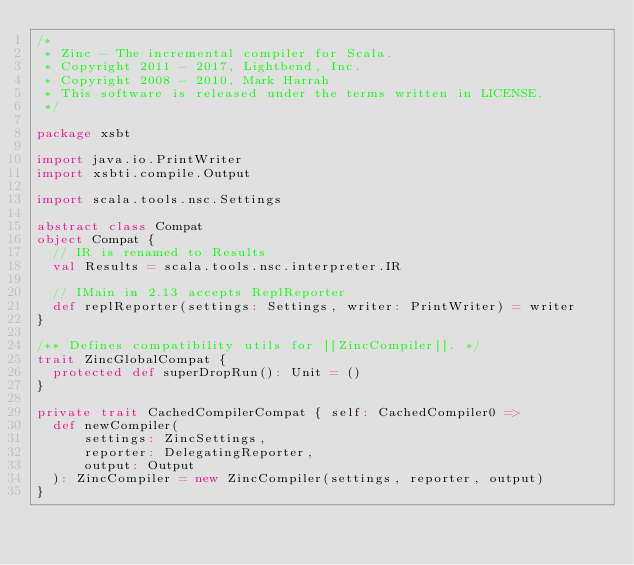<code> <loc_0><loc_0><loc_500><loc_500><_Scala_>/*
 * Zinc - The incremental compiler for Scala.
 * Copyright 2011 - 2017, Lightbend, Inc.
 * Copyright 2008 - 2010, Mark Harrah
 * This software is released under the terms written in LICENSE.
 */

package xsbt

import java.io.PrintWriter
import xsbti.compile.Output

import scala.tools.nsc.Settings

abstract class Compat
object Compat {
  // IR is renamed to Results
  val Results = scala.tools.nsc.interpreter.IR

  // IMain in 2.13 accepts ReplReporter
  def replReporter(settings: Settings, writer: PrintWriter) = writer
}

/** Defines compatibility utils for [[ZincCompiler]]. */
trait ZincGlobalCompat {
  protected def superDropRun(): Unit = ()
}

private trait CachedCompilerCompat { self: CachedCompiler0 =>
  def newCompiler(
      settings: ZincSettings,
      reporter: DelegatingReporter,
      output: Output
  ): ZincCompiler = new ZincCompiler(settings, reporter, output)
}
</code> 